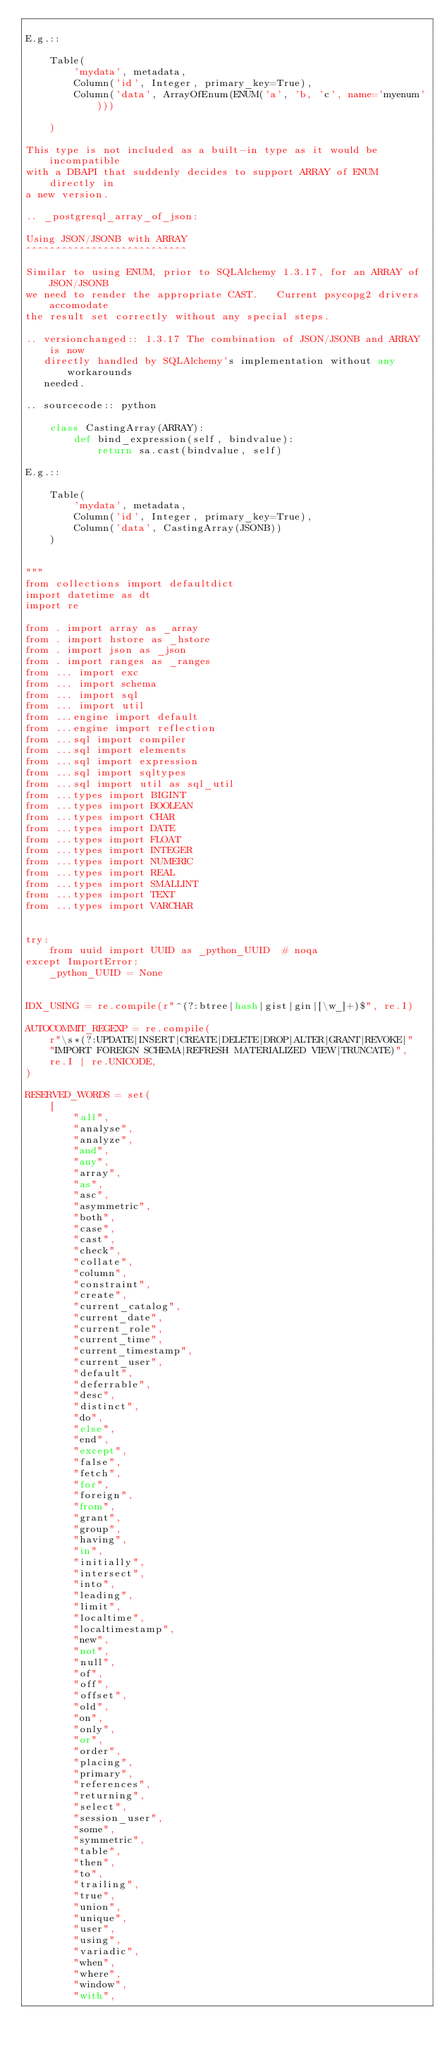Convert code to text. <code><loc_0><loc_0><loc_500><loc_500><_Python_>
E.g.::

    Table(
        'mydata', metadata,
        Column('id', Integer, primary_key=True),
        Column('data', ArrayOfEnum(ENUM('a', 'b, 'c', name='myenum')))

    )

This type is not included as a built-in type as it would be incompatible
with a DBAPI that suddenly decides to support ARRAY of ENUM directly in
a new version.

.. _postgresql_array_of_json:

Using JSON/JSONB with ARRAY
^^^^^^^^^^^^^^^^^^^^^^^^^^^

Similar to using ENUM, prior to SQLAlchemy 1.3.17, for an ARRAY of JSON/JSONB
we need to render the appropriate CAST.   Current psycopg2 drivers accomodate
the result set correctly without any special steps.

.. versionchanged:: 1.3.17 The combination of JSON/JSONB and ARRAY is now
   directly handled by SQLAlchemy's implementation without any workarounds
   needed.

.. sourcecode:: python

    class CastingArray(ARRAY):
        def bind_expression(self, bindvalue):
            return sa.cast(bindvalue, self)

E.g.::

    Table(
        'mydata', metadata,
        Column('id', Integer, primary_key=True),
        Column('data', CastingArray(JSONB))
    )


"""
from collections import defaultdict
import datetime as dt
import re

from . import array as _array
from . import hstore as _hstore
from . import json as _json
from . import ranges as _ranges
from ... import exc
from ... import schema
from ... import sql
from ... import util
from ...engine import default
from ...engine import reflection
from ...sql import compiler
from ...sql import elements
from ...sql import expression
from ...sql import sqltypes
from ...sql import util as sql_util
from ...types import BIGINT
from ...types import BOOLEAN
from ...types import CHAR
from ...types import DATE
from ...types import FLOAT
from ...types import INTEGER
from ...types import NUMERIC
from ...types import REAL
from ...types import SMALLINT
from ...types import TEXT
from ...types import VARCHAR


try:
    from uuid import UUID as _python_UUID  # noqa
except ImportError:
    _python_UUID = None


IDX_USING = re.compile(r"^(?:btree|hash|gist|gin|[\w_]+)$", re.I)

AUTOCOMMIT_REGEXP = re.compile(
    r"\s*(?:UPDATE|INSERT|CREATE|DELETE|DROP|ALTER|GRANT|REVOKE|"
    "IMPORT FOREIGN SCHEMA|REFRESH MATERIALIZED VIEW|TRUNCATE)",
    re.I | re.UNICODE,
)

RESERVED_WORDS = set(
    [
        "all",
        "analyse",
        "analyze",
        "and",
        "any",
        "array",
        "as",
        "asc",
        "asymmetric",
        "both",
        "case",
        "cast",
        "check",
        "collate",
        "column",
        "constraint",
        "create",
        "current_catalog",
        "current_date",
        "current_role",
        "current_time",
        "current_timestamp",
        "current_user",
        "default",
        "deferrable",
        "desc",
        "distinct",
        "do",
        "else",
        "end",
        "except",
        "false",
        "fetch",
        "for",
        "foreign",
        "from",
        "grant",
        "group",
        "having",
        "in",
        "initially",
        "intersect",
        "into",
        "leading",
        "limit",
        "localtime",
        "localtimestamp",
        "new",
        "not",
        "null",
        "of",
        "off",
        "offset",
        "old",
        "on",
        "only",
        "or",
        "order",
        "placing",
        "primary",
        "references",
        "returning",
        "select",
        "session_user",
        "some",
        "symmetric",
        "table",
        "then",
        "to",
        "trailing",
        "true",
        "union",
        "unique",
        "user",
        "using",
        "variadic",
        "when",
        "where",
        "window",
        "with",</code> 